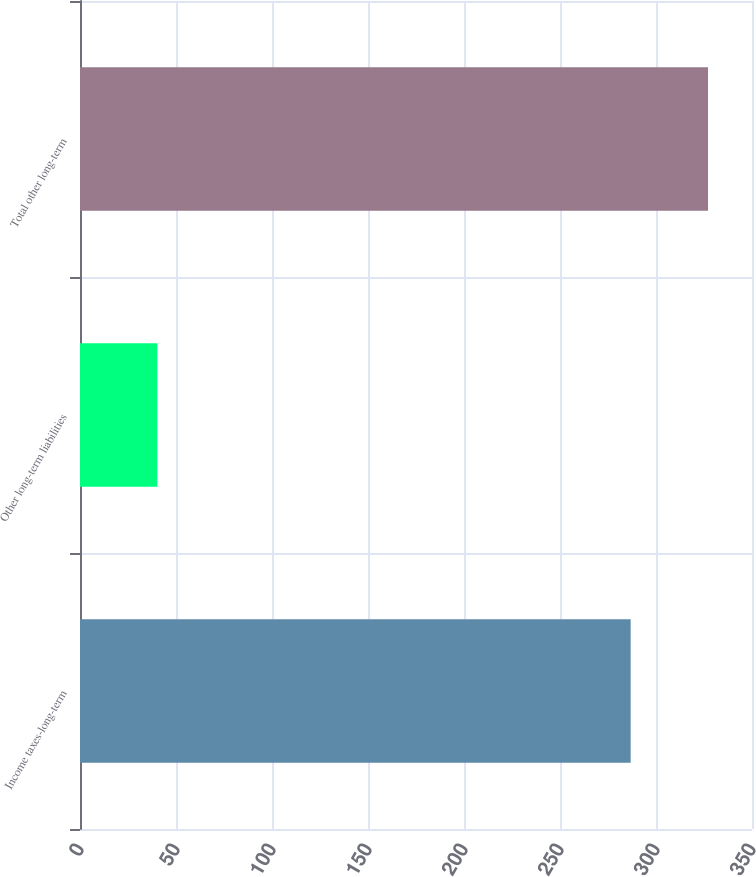<chart> <loc_0><loc_0><loc_500><loc_500><bar_chart><fcel>Income taxes-long-term<fcel>Other long-term liabilities<fcel>Total other long-term<nl><fcel>286.8<fcel>40.3<fcel>327.1<nl></chart> 